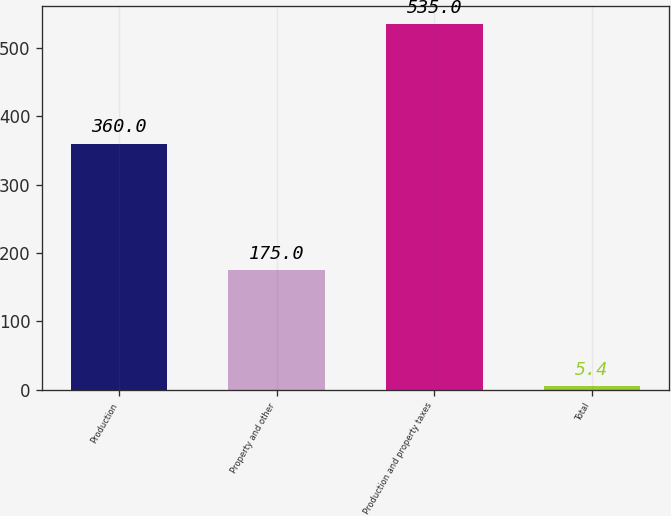Convert chart. <chart><loc_0><loc_0><loc_500><loc_500><bar_chart><fcel>Production<fcel>Property and other<fcel>Production and property taxes<fcel>Total<nl><fcel>360<fcel>175<fcel>535<fcel>5.4<nl></chart> 